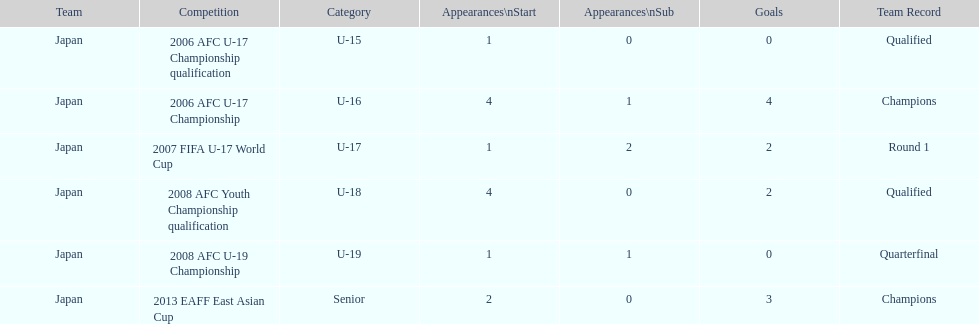In which major competitions did yoichiro kakitani have at least 3 starts? 2006 AFC U-17 Championship, 2008 AFC Youth Championship qualification. 